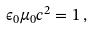Convert formula to latex. <formula><loc_0><loc_0><loc_500><loc_500>\epsilon _ { 0 } \mu _ { 0 } c ^ { 2 } = 1 \, ,</formula> 